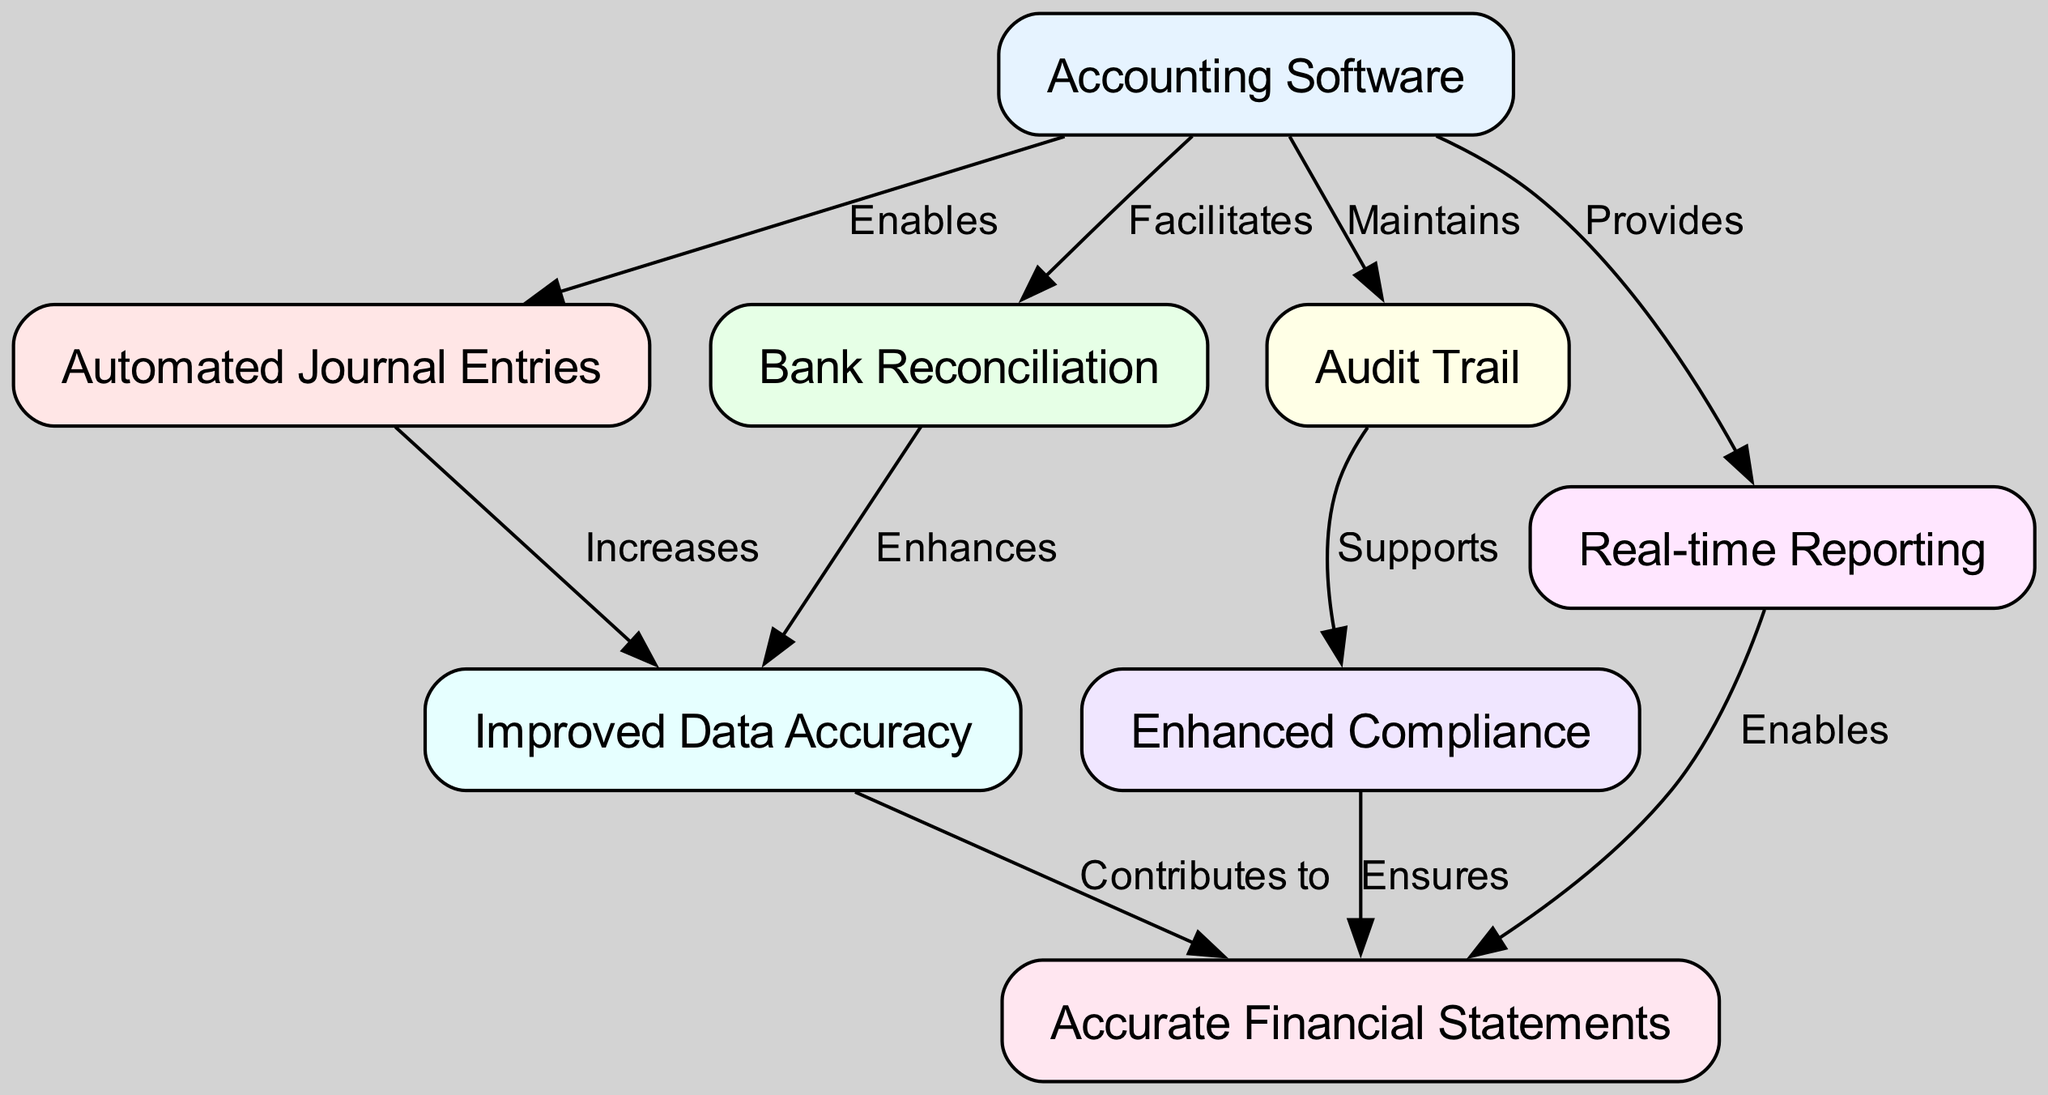What is one feature of accounting software that enables automated journal entries? Referring to the diagram, the edge labeled "Enables" connects "Accounting Software" to "Automated Journal Entries," indicating that accounting software has the feature that allows for automated entries.
Answer: Automated Journal Entries How many nodes are represented in the diagram? By counting the distinct entities depicted in the diagram, we identify eight nodes: Accounting Software, Automated Journal Entries, Bank Reconciliation, Audit Trail, Real-time Reporting, Improved Data Accuracy, Enhanced Compliance, and Accurate Financial Statements.
Answer: Eight Which feature facilitates bank reconciliation? The diagram shows that the edge labeled "Facilitates" directly connects "Accounting Software" to "Bank Reconciliation," indicating its role in supporting this feature.
Answer: Bank Reconciliation What do automated journal entries contribute to? The connection labeled "Increases" between "Automated Journal Entries" and "Improved Data Accuracy" in the diagram reveals that automated entries have a positive impact on enhancing data accuracy.
Answer: Improved Data Accuracy Which feature ensures enhanced compliance in financial reporting? Reviewing the diagram, the edge labeled "Supports" links "Audit Trail" to "Enhanced Compliance," illustrating that the audit trail feature plays a crucial role in ensuring compliance.
Answer: Enhanced Compliance What relationship does real-time reporting have with financial statements? The diagram establishes a relationship where "Real-time Reporting" is connected to "Accurate Financial Statements" through the label "Enables," indicating that real-time reporting is a key enabler for generating financial statements.
Answer: Enables How does improved data accuracy affect financial statements? The connection labeled "Contributes to" demonstrates that "Improved Data Accuracy" has a beneficial impact on the quality of "Accurate Financial Statements," showing that accuracy is fundamental to financial reporting.
Answer: Contributes to Which feature maintains an audit trail? The edge labeled "Maintains" directly connects "Accounting Software" to "Audit Trail" in the diagram, indicating that the accounting software is responsible for the maintenance of the audit trail feature.
Answer: Audit Trail 